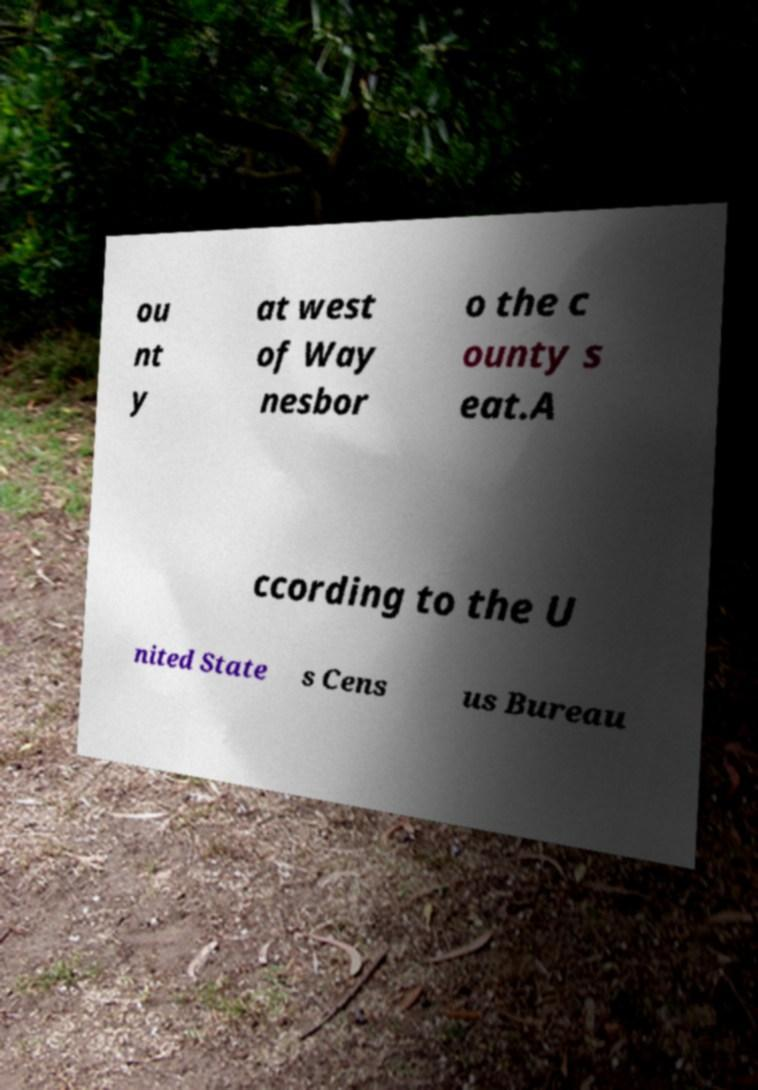Please identify and transcribe the text found in this image. ou nt y at west of Way nesbor o the c ounty s eat.A ccording to the U nited State s Cens us Bureau 